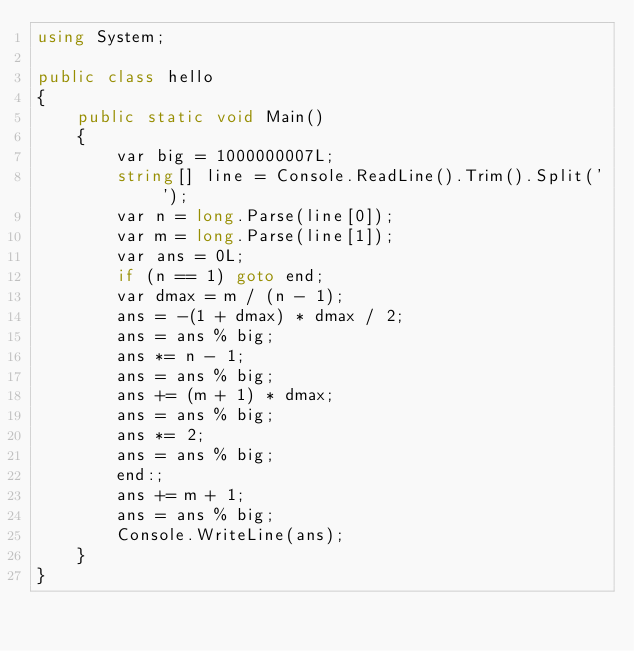<code> <loc_0><loc_0><loc_500><loc_500><_C#_>using System;

public class hello
{
    public static void Main()
    {
        var big = 1000000007L;
        string[] line = Console.ReadLine().Trim().Split(' ');
        var n = long.Parse(line[0]);
        var m = long.Parse(line[1]);
        var ans = 0L;
        if (n == 1) goto end;
        var dmax = m / (n - 1);
        ans = -(1 + dmax) * dmax / 2;
        ans = ans % big;
        ans *= n - 1;
        ans = ans % big;
        ans += (m + 1) * dmax;
        ans = ans % big;
        ans *= 2;
        ans = ans % big;
        end:;
        ans += m + 1;
        ans = ans % big;
        Console.WriteLine(ans);
    }
}</code> 